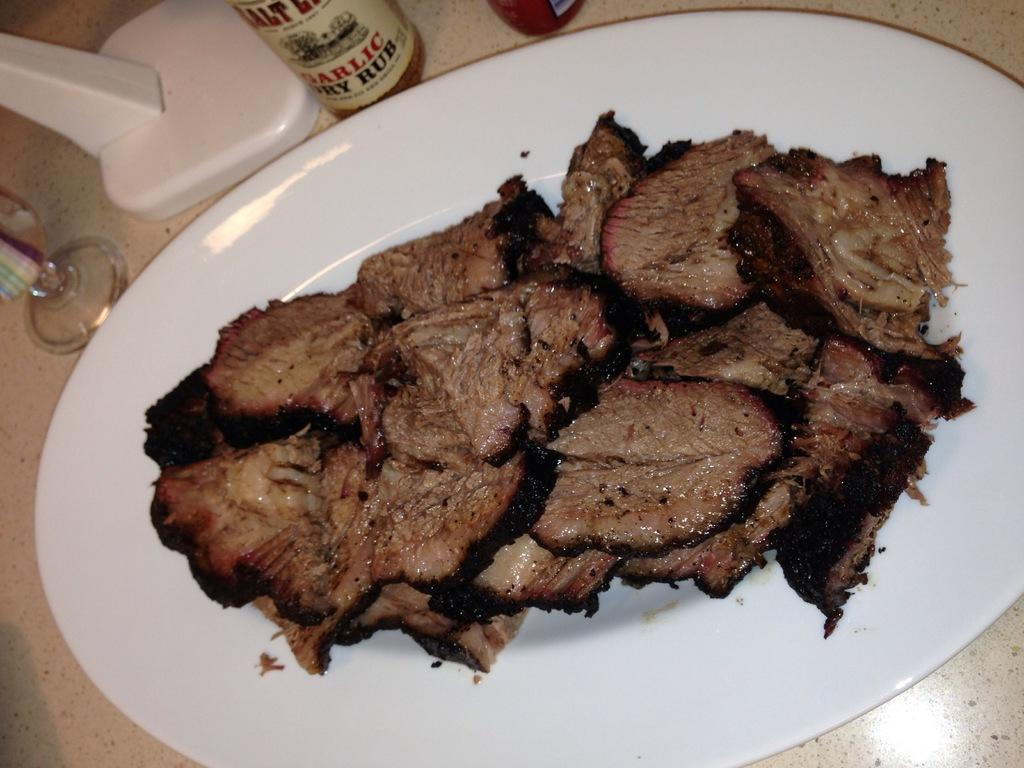<image>
Give a short and clear explanation of the subsequent image. A bottle of garlic rub sauce for meat. 